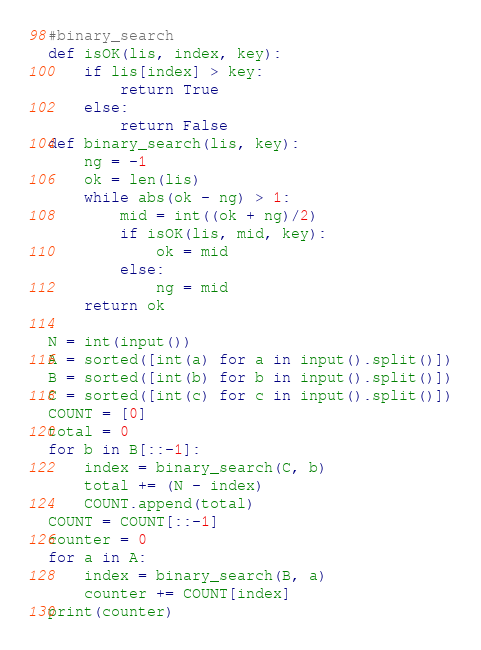Convert code to text. <code><loc_0><loc_0><loc_500><loc_500><_Python_>#binary_search
def isOK(lis, index, key):
    if lis[index] > key:
        return True
    else:
        return False
def binary_search(lis, key):
    ng = -1
    ok = len(lis)
    while abs(ok - ng) > 1:
        mid = int((ok + ng)/2)
        if isOK(lis, mid, key):
            ok = mid
        else:
            ng = mid
    return ok

N = int(input())
A = sorted([int(a) for a in input().split()])
B = sorted([int(b) for b in input().split()])
C = sorted([int(c) for c in input().split()])
COUNT = [0]
total = 0
for b in B[::-1]:
    index = binary_search(C, b)
    total += (N - index)
    COUNT.append(total)
COUNT = COUNT[::-1]
counter = 0
for a in A:
    index = binary_search(B, a)
    counter += COUNT[index]
print(counter)</code> 